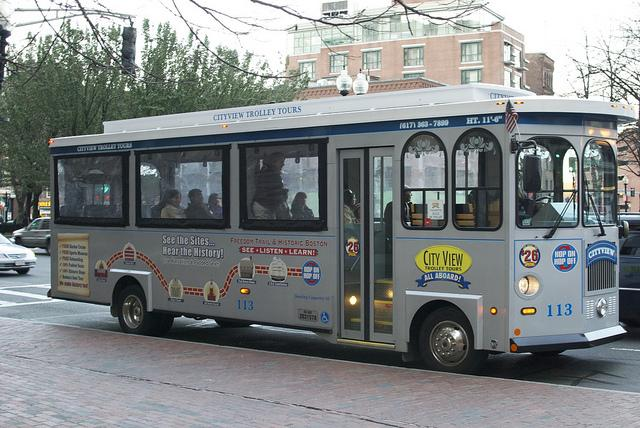What is the bus primarily used for? tours 